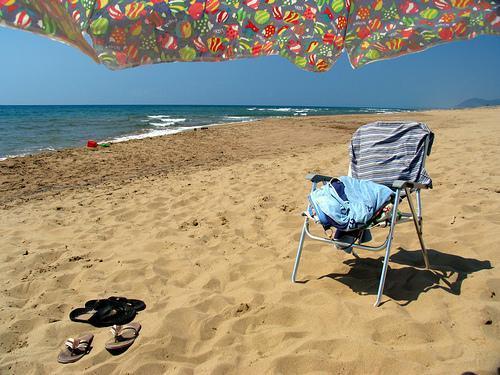How many people are skateboarding across cone?
Give a very brief answer. 0. 